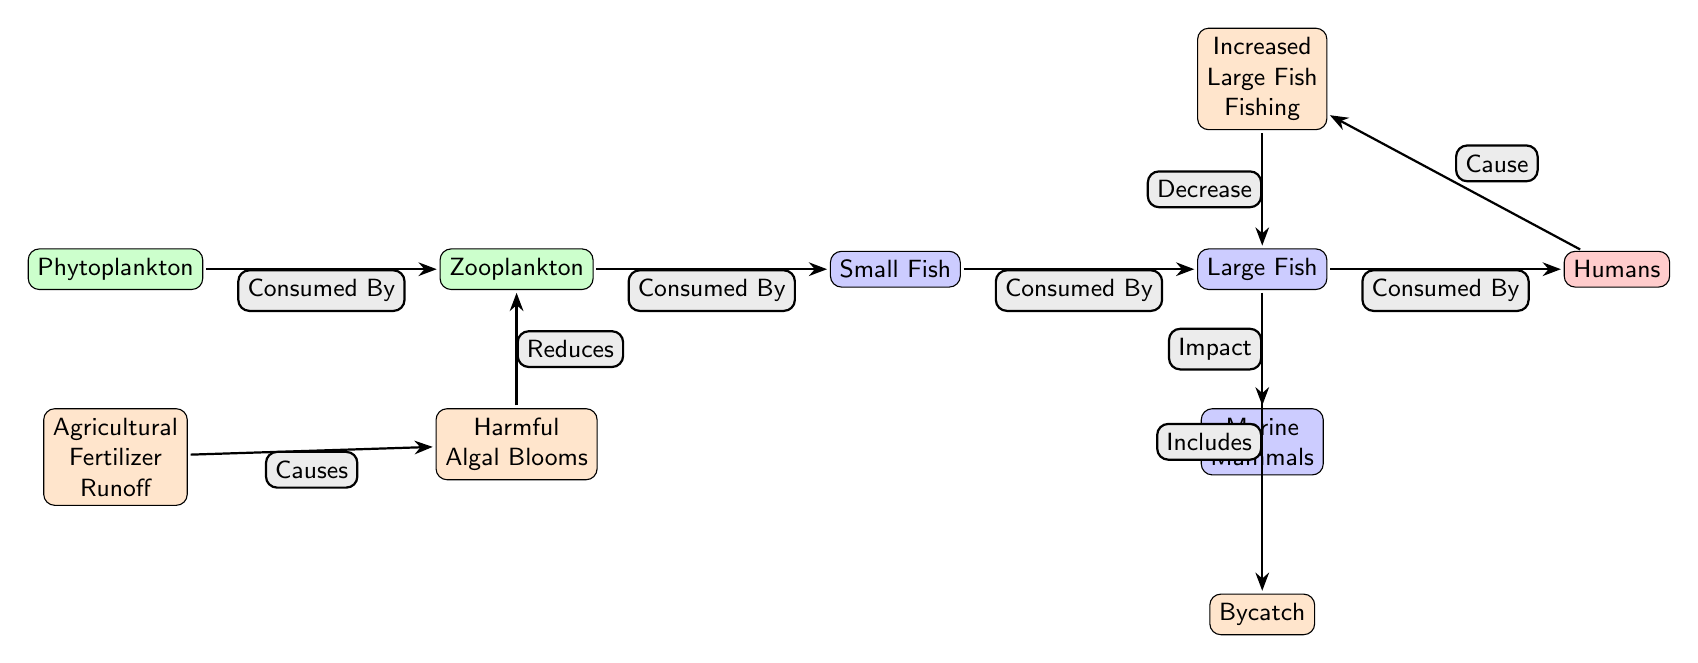What are the starting points of the food chain in the diagram? The food chain begins with "Phytoplankton" and "Zooplankton," as they are the primary producers and initial consumers in the chain.
Answer: Phytoplankton, Zooplankton How many nodes are in the food chain? Counting all the distinct nodes listed in the diagram, we have Phytoplankton, Zooplankton, Small Fish, Large Fish, Humans, Marine Mammals, and impacts like Increased Large Fish Fishing, Agricultural Fertilizer Runoff, Harmful Algal Blooms, and Bycatch. This totals to 11 nodes.
Answer: 11 What effect does "Increased Large Fish Fishing" have on "Large Fish"? The relationship depicted in the diagram shows that "Increased Large Fish Fishing" causes a "Decrease" in "Large Fish." Thus, overfishing directly reduces their population.
Answer: Decrease What happens to "Zooplankton" when "Harmful Algal Blooms" occur? The diagram indicates that "Harmful Algal Blooms" reduce the availability of "Zooplankton," implying that they suffer a decline in population due to the excessive algae.
Answer: Reduces What is the impact of "Large Fish" on "Marine Mammals"? The diagram illustrates that "Large Fish" includes "Bycatch," which signifies that "Marine Mammals" are negatively impacted as they may be caught unintentionally in fisheries targeting "Large Fish."
Answer: Impact What is the primary cause of "Harmful Algal Blooms"? According to the diagram, "Harmful Algal Blooms" are caused by the "Agricultural Fertilizer Runoff," correlating the input from agriculture to an ecological consequence in the marine environment.
Answer: Agricultural Fertilizer Runoff How do "Humans" relate to the fishing practices in the chain? The diagram shows that "Humans" are the source of "Increased Large Fish Fishing," indicating a direct influence of human activity on the fishing levels of large fish populations.
Answer: Cause What is the connection flow from "Phytoplankton" to "Humans"? The flow from "Phytoplankton" to "Humans" follows this sequence: Phytoplankton is consumed by Zooplankton, Zooplankton is consumed by Small Fish, Small Fish are consumed by Large Fish, and finally, Large Fish are consumed by Humans, demonstrating a straight energy transfer through each level.
Answer: Phytoplankton → Zooplankton → Small Fish → Large Fish → Humans 